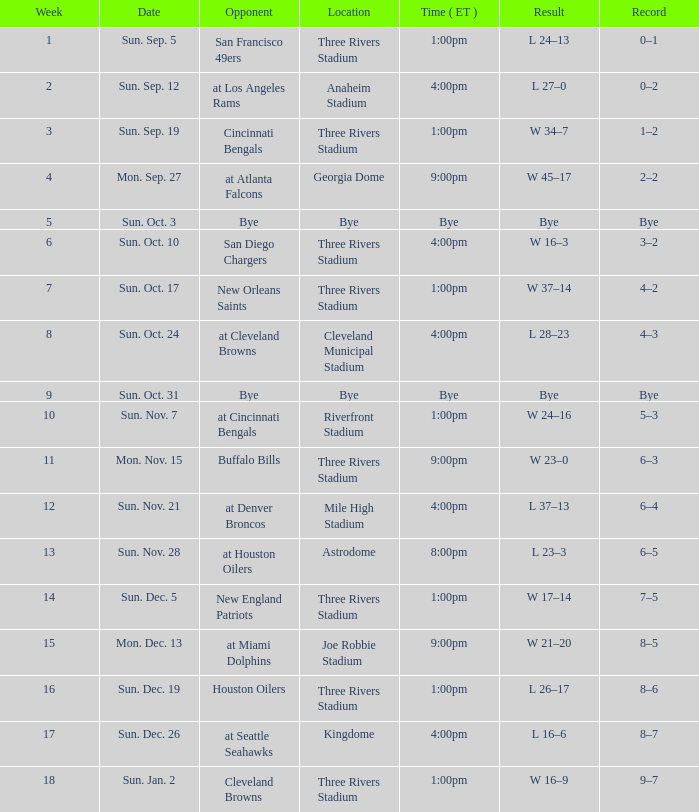What week that shows a game record of 0–1? 1.0. 